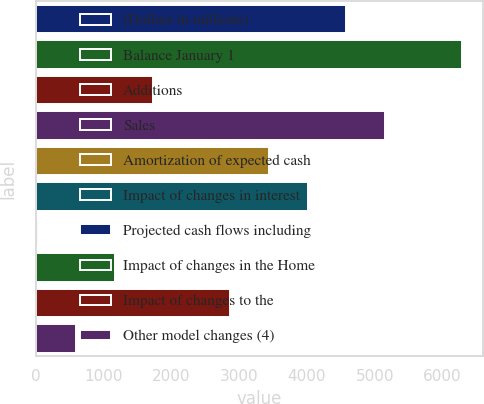Convert chart. <chart><loc_0><loc_0><loc_500><loc_500><bar_chart><fcel>(Dollars in millions)<fcel>Balance January 1<fcel>Additions<fcel>Sales<fcel>Amortization of expected cash<fcel>Impact of changes in interest<fcel>Projected cash flows including<fcel>Impact of changes in the Home<fcel>Impact of changes to the<fcel>Other model changes (4)<nl><fcel>4578.2<fcel>6284.9<fcel>1733.7<fcel>5147.1<fcel>3440.4<fcel>4009.3<fcel>27<fcel>1164.8<fcel>2871.5<fcel>595.9<nl></chart> 